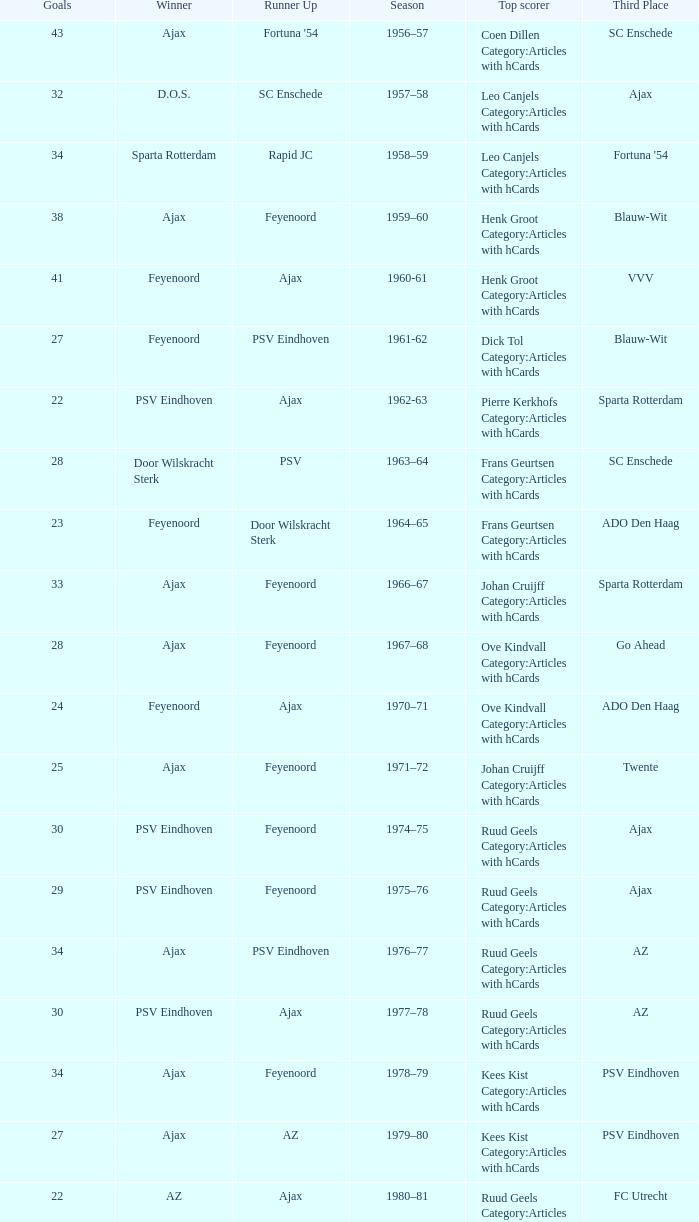When twente came in third place and ajax was the winner what are the seasons? 1971–72, 1989-90. 